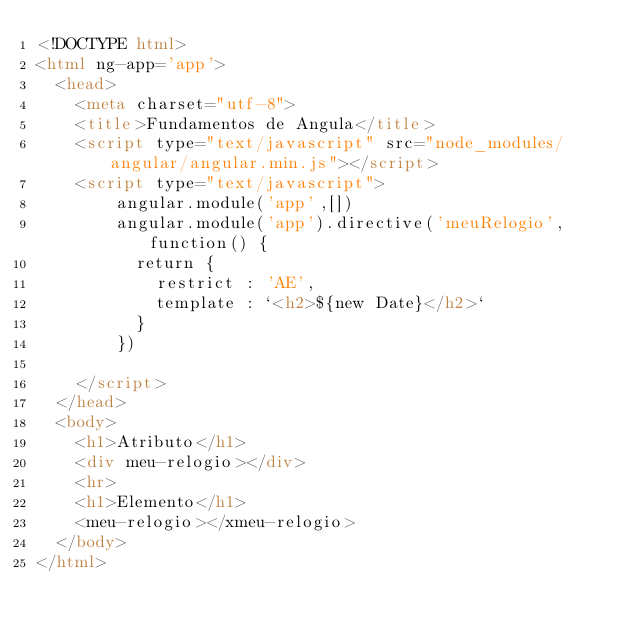Convert code to text. <code><loc_0><loc_0><loc_500><loc_500><_HTML_><!DOCTYPE html>
<html ng-app='app'>
  <head>
    <meta charset="utf-8">
    <title>Fundamentos de Angula</title>
    <script type="text/javascript" src="node_modules/angular/angular.min.js"></script>
    <script type="text/javascript">
        angular.module('app',[])
        angular.module('app').directive('meuRelogio', function() {
          return {
            restrict : 'AE',
            template : `<h2>${new Date}</h2>`
          }
        })

    </script>
  </head>
  <body>
    <h1>Atributo</h1>
    <div meu-relogio></div>
    <hr>
    <h1>Elemento</h1>
    <meu-relogio></xmeu-relogio>
  </body>
</html>
</code> 